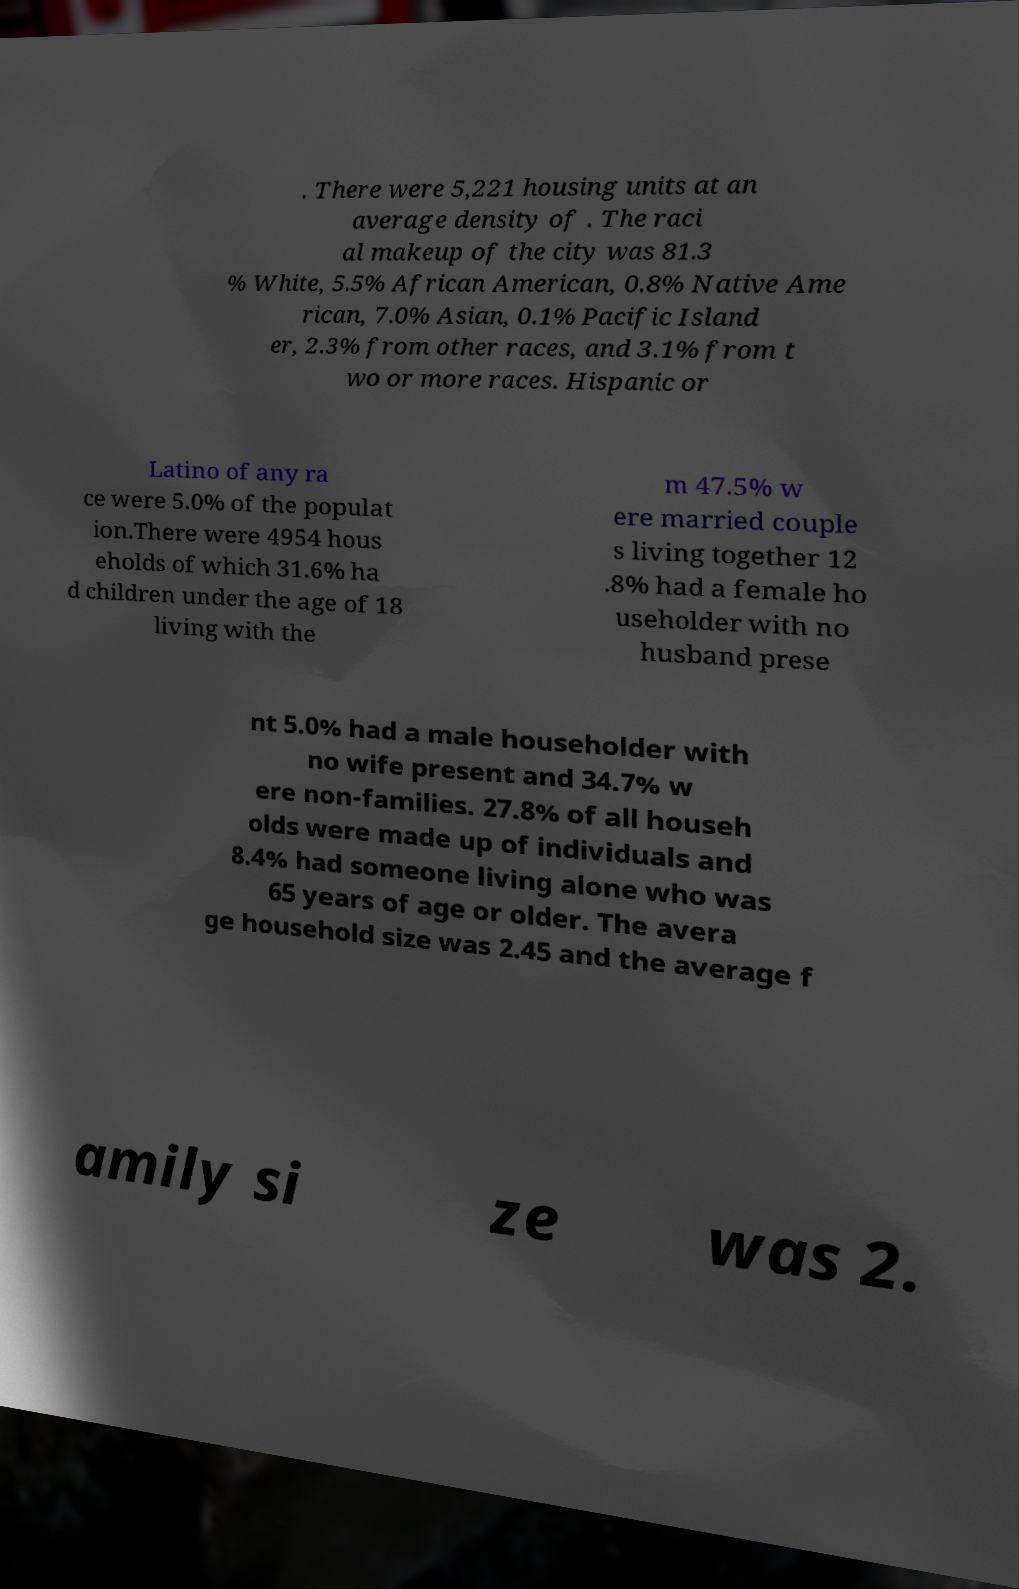Can you accurately transcribe the text from the provided image for me? . There were 5,221 housing units at an average density of . The raci al makeup of the city was 81.3 % White, 5.5% African American, 0.8% Native Ame rican, 7.0% Asian, 0.1% Pacific Island er, 2.3% from other races, and 3.1% from t wo or more races. Hispanic or Latino of any ra ce were 5.0% of the populat ion.There were 4954 hous eholds of which 31.6% ha d children under the age of 18 living with the m 47.5% w ere married couple s living together 12 .8% had a female ho useholder with no husband prese nt 5.0% had a male householder with no wife present and 34.7% w ere non-families. 27.8% of all househ olds were made up of individuals and 8.4% had someone living alone who was 65 years of age or older. The avera ge household size was 2.45 and the average f amily si ze was 2. 